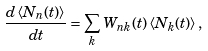Convert formula to latex. <formula><loc_0><loc_0><loc_500><loc_500>\frac { d \left \langle N _ { n } ( t ) \right \rangle } { d t } = \sum _ { k } W _ { n k } ( t ) \left \langle N _ { k } ( t ) \right \rangle ,</formula> 